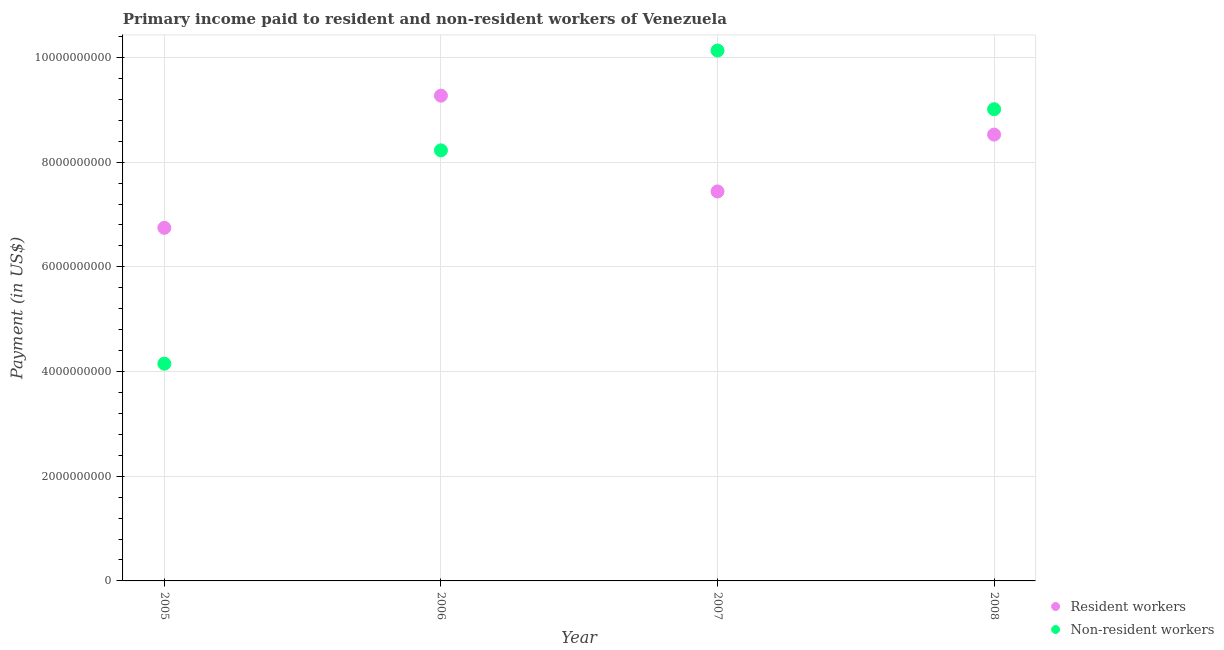How many different coloured dotlines are there?
Your answer should be very brief. 2. Is the number of dotlines equal to the number of legend labels?
Your answer should be very brief. Yes. What is the payment made to non-resident workers in 2005?
Give a very brief answer. 4.15e+09. Across all years, what is the maximum payment made to resident workers?
Give a very brief answer. 9.27e+09. Across all years, what is the minimum payment made to non-resident workers?
Give a very brief answer. 4.15e+09. What is the total payment made to resident workers in the graph?
Offer a very short reply. 3.20e+1. What is the difference between the payment made to non-resident workers in 2007 and that in 2008?
Offer a very short reply. 1.12e+09. What is the difference between the payment made to non-resident workers in 2006 and the payment made to resident workers in 2005?
Provide a short and direct response. 1.48e+09. What is the average payment made to resident workers per year?
Offer a very short reply. 8.00e+09. In the year 2008, what is the difference between the payment made to resident workers and payment made to non-resident workers?
Your answer should be compact. -4.85e+08. In how many years, is the payment made to non-resident workers greater than 3200000000 US$?
Your answer should be very brief. 4. What is the ratio of the payment made to non-resident workers in 2005 to that in 2008?
Offer a very short reply. 0.46. Is the payment made to non-resident workers in 2005 less than that in 2008?
Your answer should be compact. Yes. What is the difference between the highest and the second highest payment made to resident workers?
Give a very brief answer. 7.44e+08. What is the difference between the highest and the lowest payment made to resident workers?
Offer a very short reply. 2.52e+09. In how many years, is the payment made to resident workers greater than the average payment made to resident workers taken over all years?
Keep it short and to the point. 2. Does the payment made to non-resident workers monotonically increase over the years?
Ensure brevity in your answer.  No. Is the payment made to resident workers strictly greater than the payment made to non-resident workers over the years?
Offer a very short reply. No. What is the difference between two consecutive major ticks on the Y-axis?
Offer a terse response. 2.00e+09. Are the values on the major ticks of Y-axis written in scientific E-notation?
Your answer should be very brief. No. Where does the legend appear in the graph?
Your answer should be compact. Bottom right. How many legend labels are there?
Your response must be concise. 2. What is the title of the graph?
Ensure brevity in your answer.  Primary income paid to resident and non-resident workers of Venezuela. What is the label or title of the X-axis?
Offer a terse response. Year. What is the label or title of the Y-axis?
Keep it short and to the point. Payment (in US$). What is the Payment (in US$) in Resident workers in 2005?
Offer a very short reply. 6.75e+09. What is the Payment (in US$) of Non-resident workers in 2005?
Provide a short and direct response. 4.15e+09. What is the Payment (in US$) in Resident workers in 2006?
Provide a succinct answer. 9.27e+09. What is the Payment (in US$) in Non-resident workers in 2006?
Offer a very short reply. 8.23e+09. What is the Payment (in US$) in Resident workers in 2007?
Give a very brief answer. 7.44e+09. What is the Payment (in US$) of Non-resident workers in 2007?
Provide a short and direct response. 1.01e+1. What is the Payment (in US$) in Resident workers in 2008?
Offer a terse response. 8.53e+09. What is the Payment (in US$) of Non-resident workers in 2008?
Make the answer very short. 9.01e+09. Across all years, what is the maximum Payment (in US$) in Resident workers?
Your answer should be compact. 9.27e+09. Across all years, what is the maximum Payment (in US$) in Non-resident workers?
Ensure brevity in your answer.  1.01e+1. Across all years, what is the minimum Payment (in US$) in Resident workers?
Provide a short and direct response. 6.75e+09. Across all years, what is the minimum Payment (in US$) of Non-resident workers?
Your response must be concise. 4.15e+09. What is the total Payment (in US$) in Resident workers in the graph?
Ensure brevity in your answer.  3.20e+1. What is the total Payment (in US$) of Non-resident workers in the graph?
Your answer should be very brief. 3.15e+1. What is the difference between the Payment (in US$) in Resident workers in 2005 and that in 2006?
Offer a very short reply. -2.52e+09. What is the difference between the Payment (in US$) of Non-resident workers in 2005 and that in 2006?
Keep it short and to the point. -4.08e+09. What is the difference between the Payment (in US$) in Resident workers in 2005 and that in 2007?
Offer a terse response. -6.95e+08. What is the difference between the Payment (in US$) of Non-resident workers in 2005 and that in 2007?
Ensure brevity in your answer.  -5.98e+09. What is the difference between the Payment (in US$) in Resident workers in 2005 and that in 2008?
Your response must be concise. -1.78e+09. What is the difference between the Payment (in US$) in Non-resident workers in 2005 and that in 2008?
Offer a terse response. -4.86e+09. What is the difference between the Payment (in US$) in Resident workers in 2006 and that in 2007?
Provide a succinct answer. 1.83e+09. What is the difference between the Payment (in US$) in Non-resident workers in 2006 and that in 2007?
Offer a terse response. -1.91e+09. What is the difference between the Payment (in US$) in Resident workers in 2006 and that in 2008?
Offer a terse response. 7.44e+08. What is the difference between the Payment (in US$) in Non-resident workers in 2006 and that in 2008?
Offer a very short reply. -7.86e+08. What is the difference between the Payment (in US$) in Resident workers in 2007 and that in 2008?
Make the answer very short. -1.09e+09. What is the difference between the Payment (in US$) of Non-resident workers in 2007 and that in 2008?
Your answer should be very brief. 1.12e+09. What is the difference between the Payment (in US$) of Resident workers in 2005 and the Payment (in US$) of Non-resident workers in 2006?
Your response must be concise. -1.48e+09. What is the difference between the Payment (in US$) in Resident workers in 2005 and the Payment (in US$) in Non-resident workers in 2007?
Keep it short and to the point. -3.39e+09. What is the difference between the Payment (in US$) in Resident workers in 2005 and the Payment (in US$) in Non-resident workers in 2008?
Offer a terse response. -2.27e+09. What is the difference between the Payment (in US$) of Resident workers in 2006 and the Payment (in US$) of Non-resident workers in 2007?
Give a very brief answer. -8.62e+08. What is the difference between the Payment (in US$) of Resident workers in 2006 and the Payment (in US$) of Non-resident workers in 2008?
Your answer should be very brief. 2.59e+08. What is the difference between the Payment (in US$) of Resident workers in 2007 and the Payment (in US$) of Non-resident workers in 2008?
Your response must be concise. -1.57e+09. What is the average Payment (in US$) in Resident workers per year?
Your answer should be very brief. 8.00e+09. What is the average Payment (in US$) of Non-resident workers per year?
Give a very brief answer. 7.88e+09. In the year 2005, what is the difference between the Payment (in US$) of Resident workers and Payment (in US$) of Non-resident workers?
Your answer should be compact. 2.60e+09. In the year 2006, what is the difference between the Payment (in US$) in Resident workers and Payment (in US$) in Non-resident workers?
Provide a short and direct response. 1.04e+09. In the year 2007, what is the difference between the Payment (in US$) of Resident workers and Payment (in US$) of Non-resident workers?
Your response must be concise. -2.69e+09. In the year 2008, what is the difference between the Payment (in US$) of Resident workers and Payment (in US$) of Non-resident workers?
Provide a short and direct response. -4.85e+08. What is the ratio of the Payment (in US$) in Resident workers in 2005 to that in 2006?
Ensure brevity in your answer.  0.73. What is the ratio of the Payment (in US$) in Non-resident workers in 2005 to that in 2006?
Provide a succinct answer. 0.5. What is the ratio of the Payment (in US$) in Resident workers in 2005 to that in 2007?
Provide a short and direct response. 0.91. What is the ratio of the Payment (in US$) in Non-resident workers in 2005 to that in 2007?
Offer a terse response. 0.41. What is the ratio of the Payment (in US$) of Resident workers in 2005 to that in 2008?
Your answer should be compact. 0.79. What is the ratio of the Payment (in US$) of Non-resident workers in 2005 to that in 2008?
Provide a short and direct response. 0.46. What is the ratio of the Payment (in US$) of Resident workers in 2006 to that in 2007?
Provide a succinct answer. 1.25. What is the ratio of the Payment (in US$) in Non-resident workers in 2006 to that in 2007?
Provide a short and direct response. 0.81. What is the ratio of the Payment (in US$) in Resident workers in 2006 to that in 2008?
Offer a terse response. 1.09. What is the ratio of the Payment (in US$) of Non-resident workers in 2006 to that in 2008?
Provide a succinct answer. 0.91. What is the ratio of the Payment (in US$) in Resident workers in 2007 to that in 2008?
Your response must be concise. 0.87. What is the ratio of the Payment (in US$) in Non-resident workers in 2007 to that in 2008?
Your answer should be compact. 1.12. What is the difference between the highest and the second highest Payment (in US$) in Resident workers?
Keep it short and to the point. 7.44e+08. What is the difference between the highest and the second highest Payment (in US$) of Non-resident workers?
Your answer should be very brief. 1.12e+09. What is the difference between the highest and the lowest Payment (in US$) of Resident workers?
Keep it short and to the point. 2.52e+09. What is the difference between the highest and the lowest Payment (in US$) in Non-resident workers?
Your answer should be compact. 5.98e+09. 